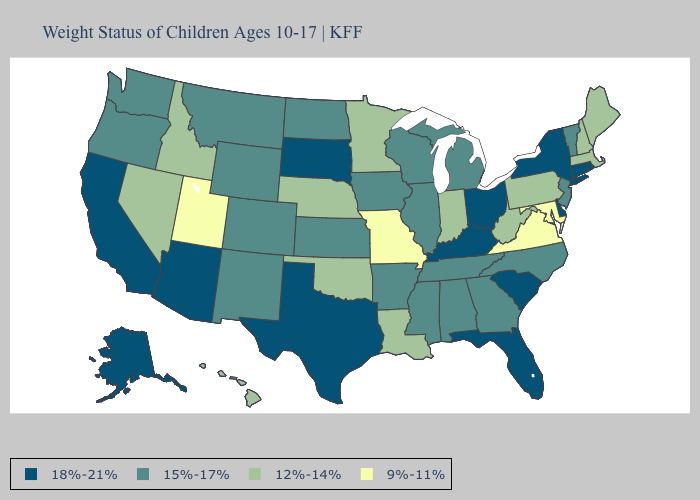Name the states that have a value in the range 15%-17%?
Quick response, please. Alabama, Arkansas, Colorado, Georgia, Illinois, Iowa, Kansas, Michigan, Mississippi, Montana, New Jersey, New Mexico, North Carolina, North Dakota, Oregon, Tennessee, Vermont, Washington, Wisconsin, Wyoming. Does Kentucky have the same value as Ohio?
Be succinct. Yes. Which states have the highest value in the USA?
Keep it brief. Alaska, Arizona, California, Connecticut, Delaware, Florida, Kentucky, New York, Ohio, Rhode Island, South Carolina, South Dakota, Texas. Does the first symbol in the legend represent the smallest category?
Write a very short answer. No. Among the states that border Colorado , which have the lowest value?
Quick response, please. Utah. What is the value of Washington?
Keep it brief. 15%-17%. What is the value of Kansas?
Concise answer only. 15%-17%. Does Alabama have the lowest value in the USA?
Write a very short answer. No. Among the states that border Virginia , does Kentucky have the highest value?
Write a very short answer. Yes. Does Washington have the highest value in the West?
Quick response, please. No. What is the highest value in the South ?
Answer briefly. 18%-21%. Which states have the highest value in the USA?
Answer briefly. Alaska, Arizona, California, Connecticut, Delaware, Florida, Kentucky, New York, Ohio, Rhode Island, South Carolina, South Dakota, Texas. Among the states that border Utah , does Arizona have the highest value?
Write a very short answer. Yes. Does Wyoming have the same value as Colorado?
Concise answer only. Yes. Does the first symbol in the legend represent the smallest category?
Short answer required. No. 